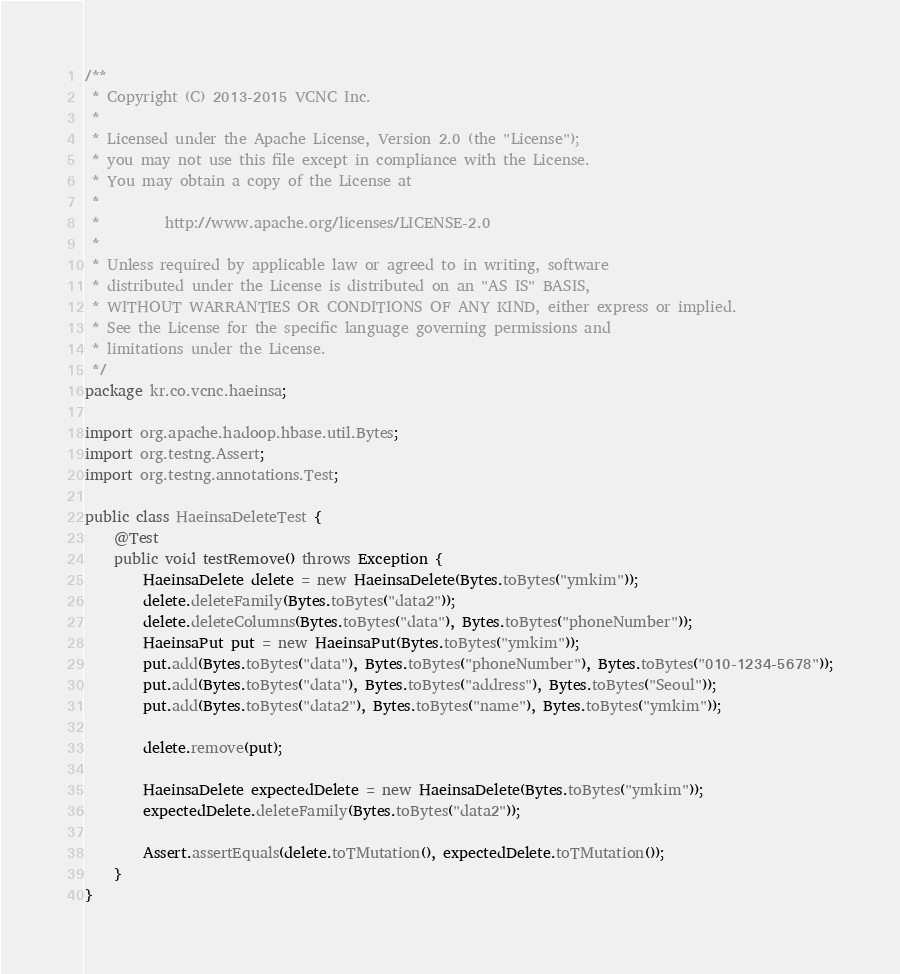Convert code to text. <code><loc_0><loc_0><loc_500><loc_500><_Java_>/**
 * Copyright (C) 2013-2015 VCNC Inc.
 *
 * Licensed under the Apache License, Version 2.0 (the "License");
 * you may not use this file except in compliance with the License.
 * You may obtain a copy of the License at
 *
 *         http://www.apache.org/licenses/LICENSE-2.0
 *
 * Unless required by applicable law or agreed to in writing, software
 * distributed under the License is distributed on an "AS IS" BASIS,
 * WITHOUT WARRANTIES OR CONDITIONS OF ANY KIND, either express or implied.
 * See the License for the specific language governing permissions and
 * limitations under the License.
 */
package kr.co.vcnc.haeinsa;

import org.apache.hadoop.hbase.util.Bytes;
import org.testng.Assert;
import org.testng.annotations.Test;

public class HaeinsaDeleteTest {
    @Test
    public void testRemove() throws Exception {
        HaeinsaDelete delete = new HaeinsaDelete(Bytes.toBytes("ymkim"));
        delete.deleteFamily(Bytes.toBytes("data2"));
        delete.deleteColumns(Bytes.toBytes("data"), Bytes.toBytes("phoneNumber"));
        HaeinsaPut put = new HaeinsaPut(Bytes.toBytes("ymkim"));
        put.add(Bytes.toBytes("data"), Bytes.toBytes("phoneNumber"), Bytes.toBytes("010-1234-5678"));
        put.add(Bytes.toBytes("data"), Bytes.toBytes("address"), Bytes.toBytes("Seoul"));
        put.add(Bytes.toBytes("data2"), Bytes.toBytes("name"), Bytes.toBytes("ymkim"));

        delete.remove(put);

        HaeinsaDelete expectedDelete = new HaeinsaDelete(Bytes.toBytes("ymkim"));
        expectedDelete.deleteFamily(Bytes.toBytes("data2"));

        Assert.assertEquals(delete.toTMutation(), expectedDelete.toTMutation());
    }
}
</code> 